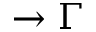Convert formula to latex. <formula><loc_0><loc_0><loc_500><loc_500>\rightarrow \Gamma</formula> 